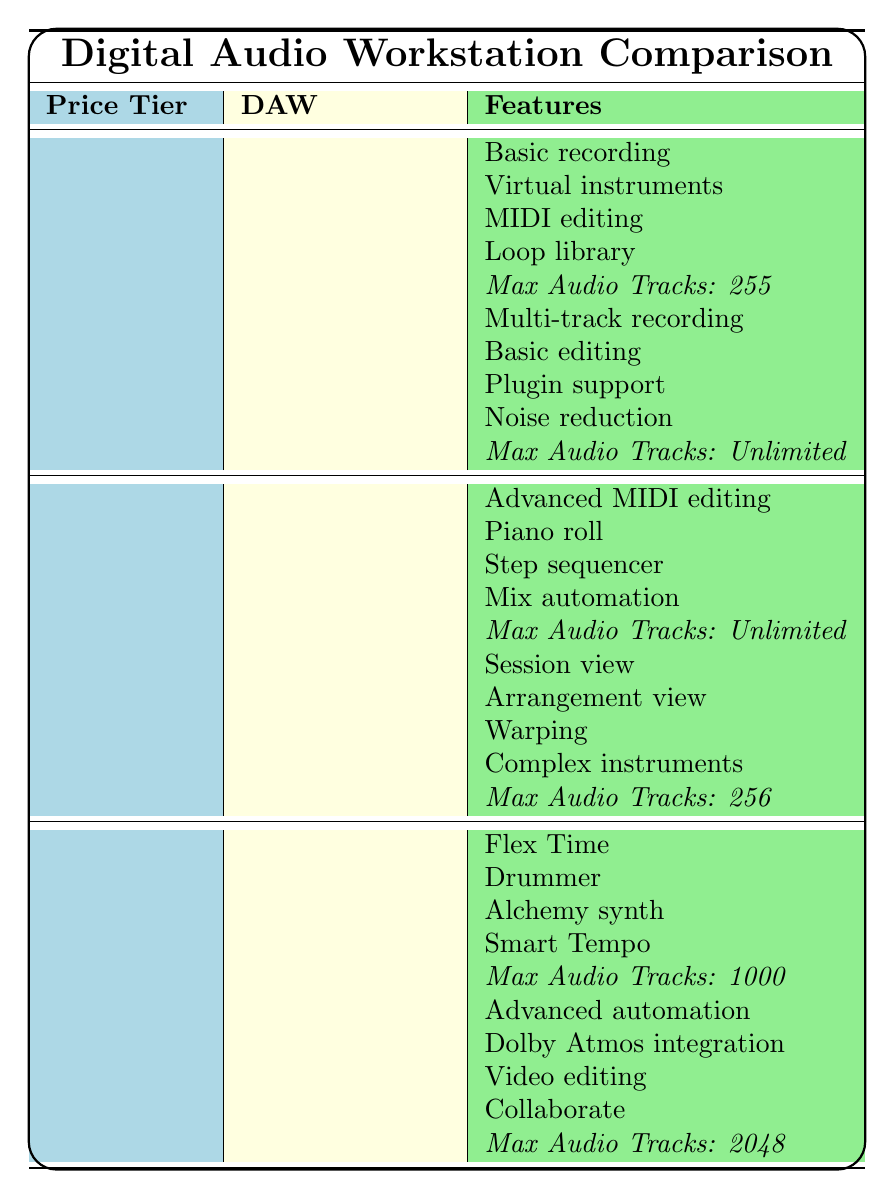What is the maximum number of audio tracks supported by Audacity? The table shows that Audacity can handle an unlimited number of audio tracks, as indicated in its Max Audio Tracks row.
Answer: Unlimited Which DAW in the Mid-Range category offers a loop library feature? The table lists the features of each DAW in the Mid-Range category, but neither FL Studio Producer Edition nor Ableton Live Standard have a loop library feature mentioned.
Answer: No What is the total number of audio tracks supported by all DAWs in the Professional category? The table indicates that Logic Pro X supports 1000 tracks and Pro Tools Ultimate supports 2048 tracks. So, 1000 + 2048 = 3048.
Answer: 3048 Do both DAWs in the Entry-Level category have mobile compatibility? GarageBand is compatible only with iOS, and Audacity has no mobile compatibility listed. Thus, not both have mobile compatibility.
Answer: No Which DAW has the most advanced features listed in the Professional category? The Professional category has Logic Pro X and Pro Tools Ultimate; comparing their features, Pro Tools Ultimate has advanced automation, Dolby Atmos integration, video editing, and collaboration, which appear more advanced overall.
Answer: Pro Tools Ultimate How many total features does FL Studio Producer Edition have compared to GarageBand? FL Studio Producer Edition lists 4 features, while GarageBand also has 4 features. Therefore, both have the same number of features.
Answer: Equal Is there a DAW in the Mid-Range category that has mobile compatibility for iOS only? The table shows that Ableton Live Standard has no mobile compatibility, and FL Studio Producer Edition is compatible with both Android and iOS. Thus, there is no DAW for iOS only in this category.
Answer: No Which price tier has a DAW that supports the most audio tracks? In the Professional category, Pro Tools Ultimate supports 2048 audio tracks, which is greater than the maximum supports listed in other tiers.
Answer: Professional tier What is the average number of audio tracks supported by all DAWs listed? The total number of tracks supported is 255 (GarageBand) + Unlimited (Audacity, considered as very large) + Unlimited (FL Studio Producer Edition) + 256 (Ableton Live Standard) + 1000 (Logic Pro X) + 2048 (Pro Tools Ultimate). The average cannot be numerically defined due to the unlimited entries, but the range varies from 255 to 2048.
Answer: Undefined Does any DAW listed support both Android and iOS? Yes, the table indicates that FL Studio Producer Edition is the only DAW listed under Mid-Range that supports both Android and iOS.
Answer: Yes 